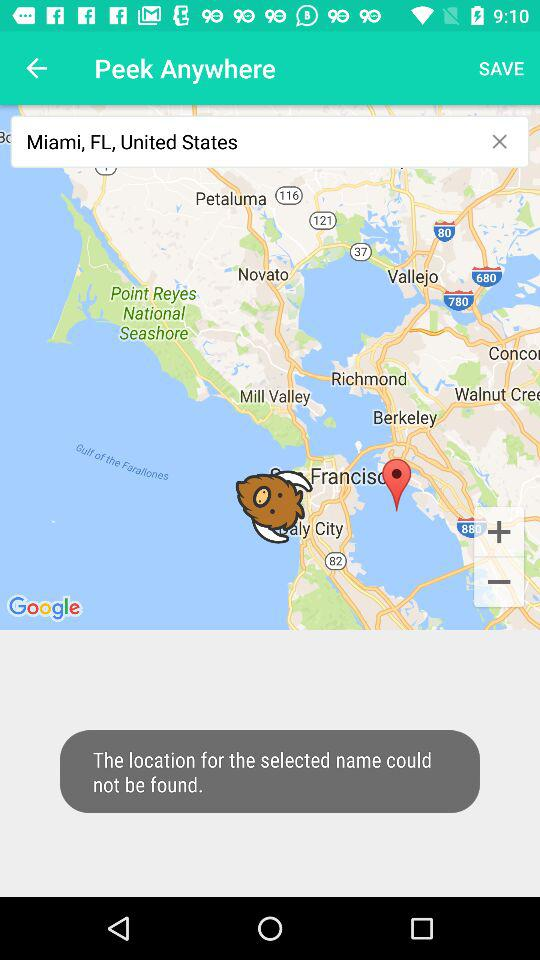What address is selected in the search bar? The selected address is "Miami, FL, United States". 